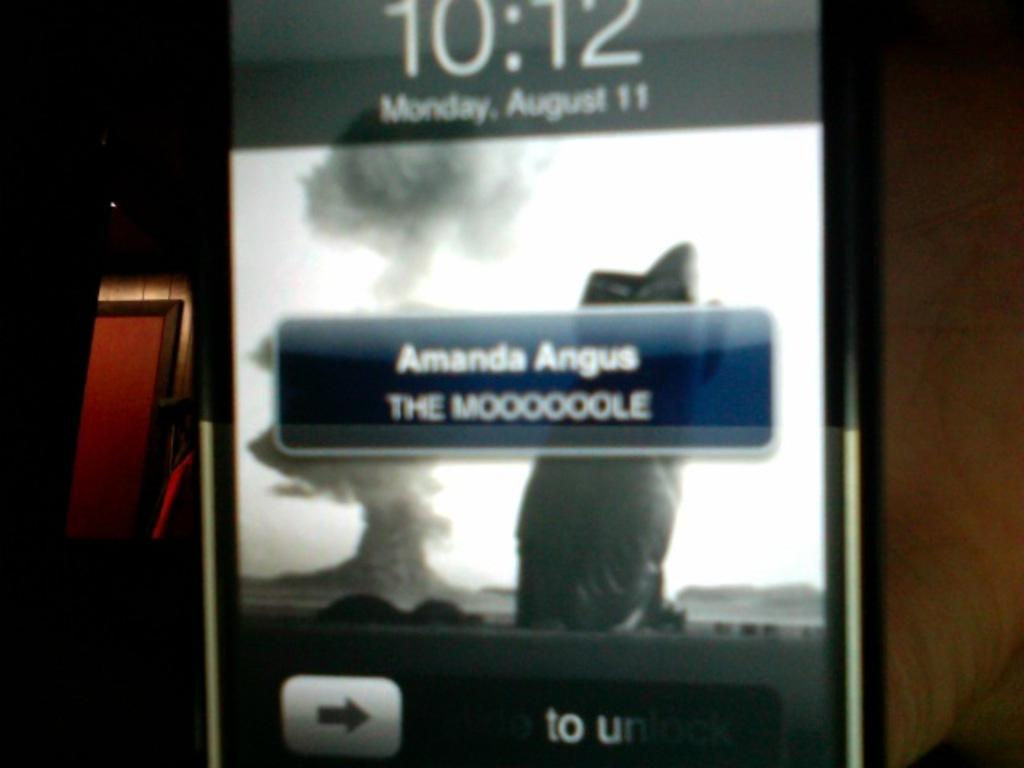Provide a one-sentence caption for the provided image. a phone with the name of Amanda on it. 